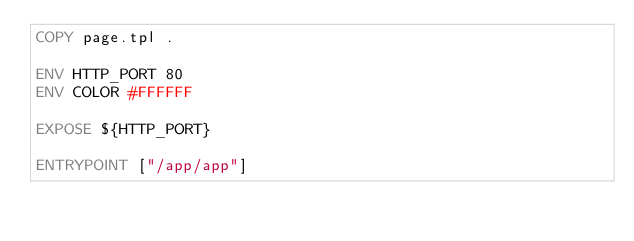Convert code to text. <code><loc_0><loc_0><loc_500><loc_500><_Dockerfile_>COPY page.tpl .

ENV HTTP_PORT 80
ENV COLOR #FFFFFF

EXPOSE ${HTTP_PORT}

ENTRYPOINT ["/app/app"]
</code> 